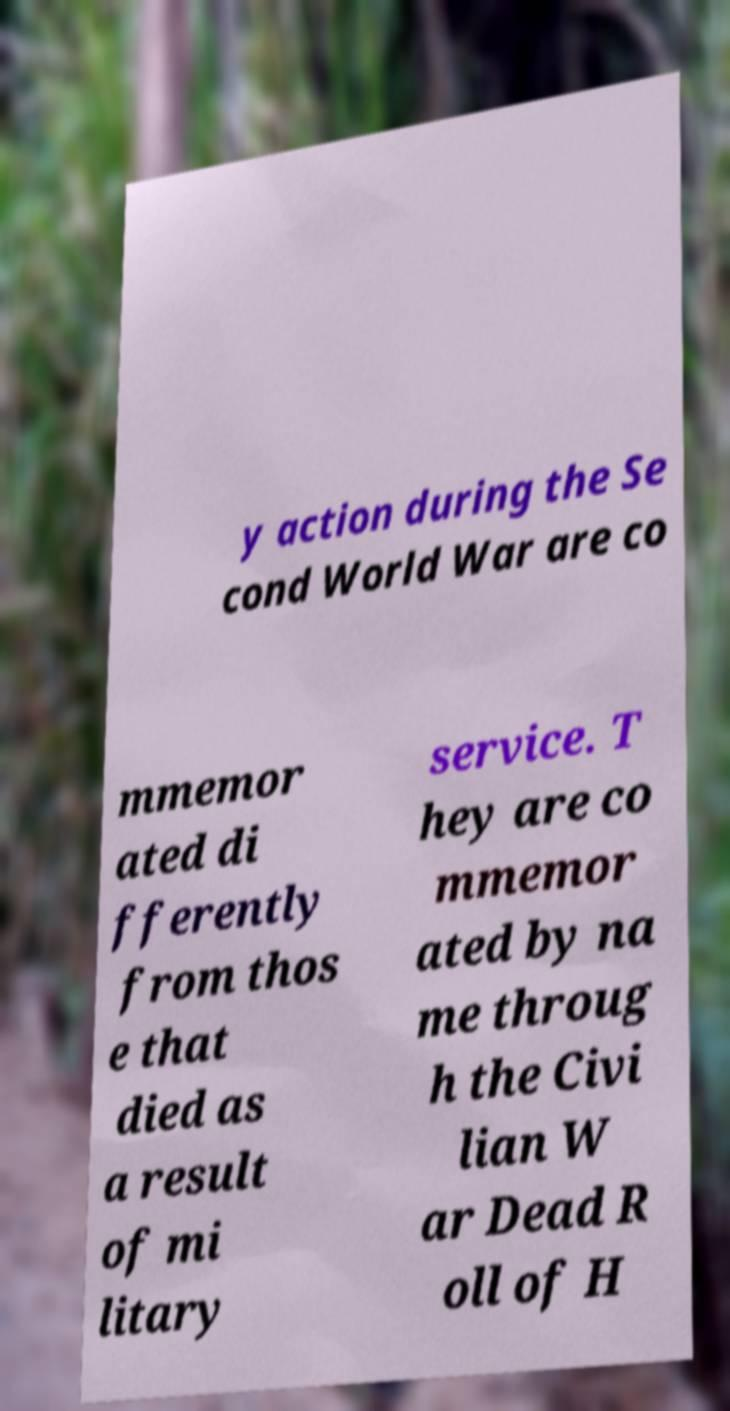I need the written content from this picture converted into text. Can you do that? y action during the Se cond World War are co mmemor ated di fferently from thos e that died as a result of mi litary service. T hey are co mmemor ated by na me throug h the Civi lian W ar Dead R oll of H 